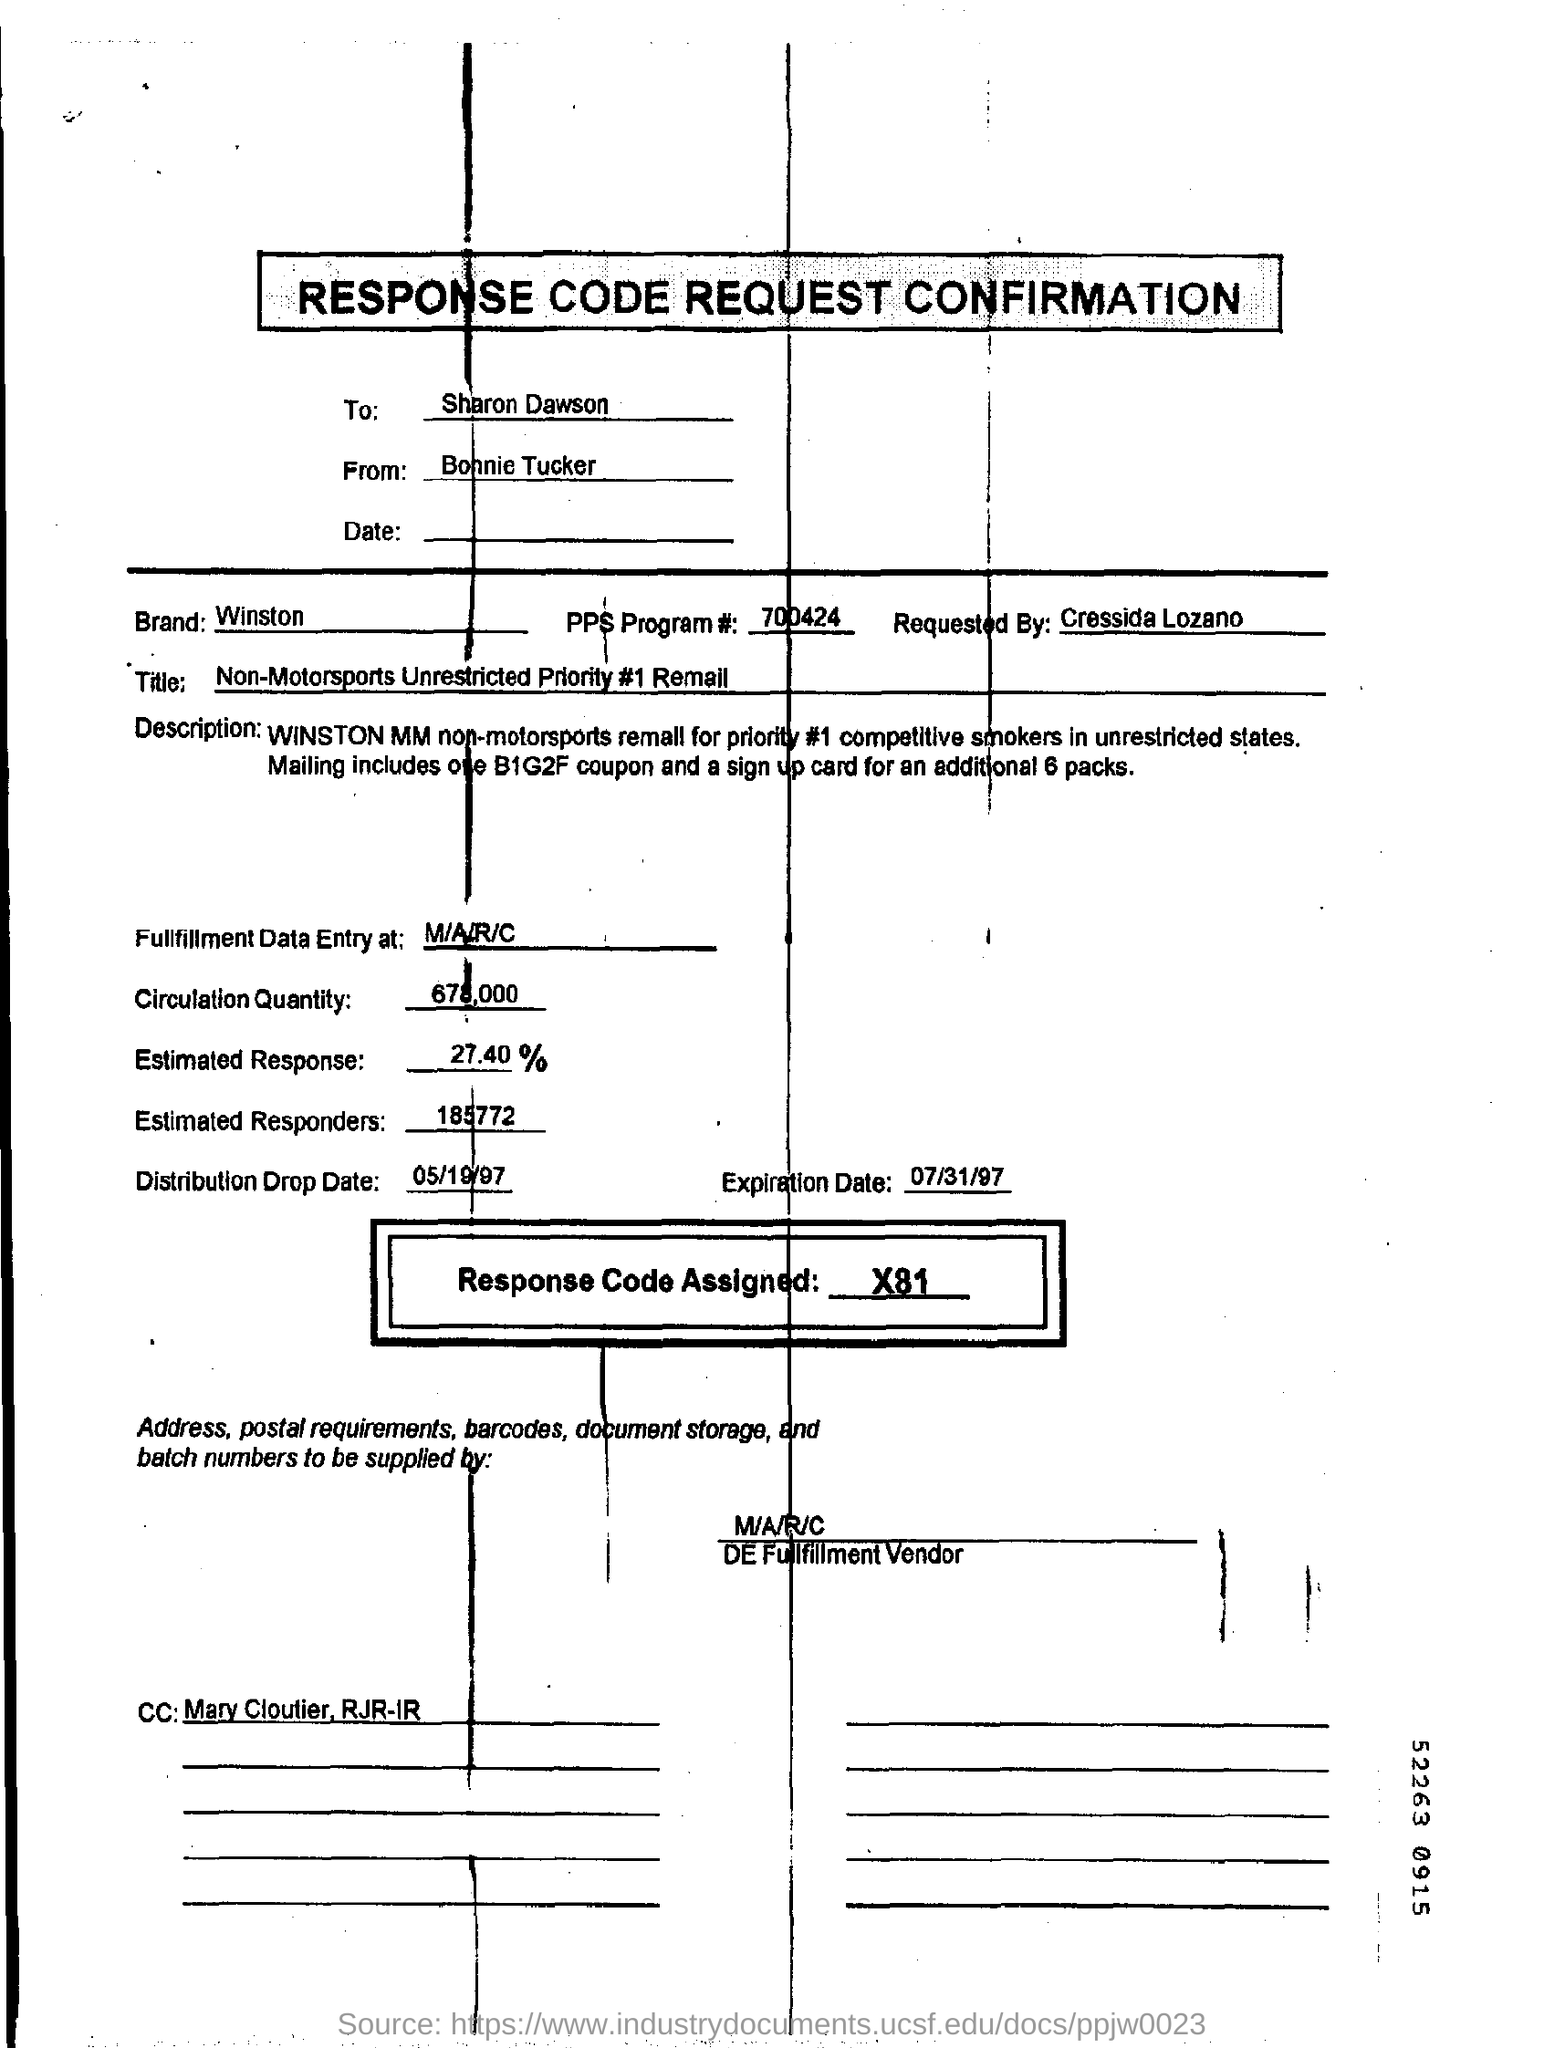Who is the sender of the response code request confirmation
Your response must be concise. Bonnie Tucker. What is the code of the pps program#?
Provide a short and direct response. 700424. 